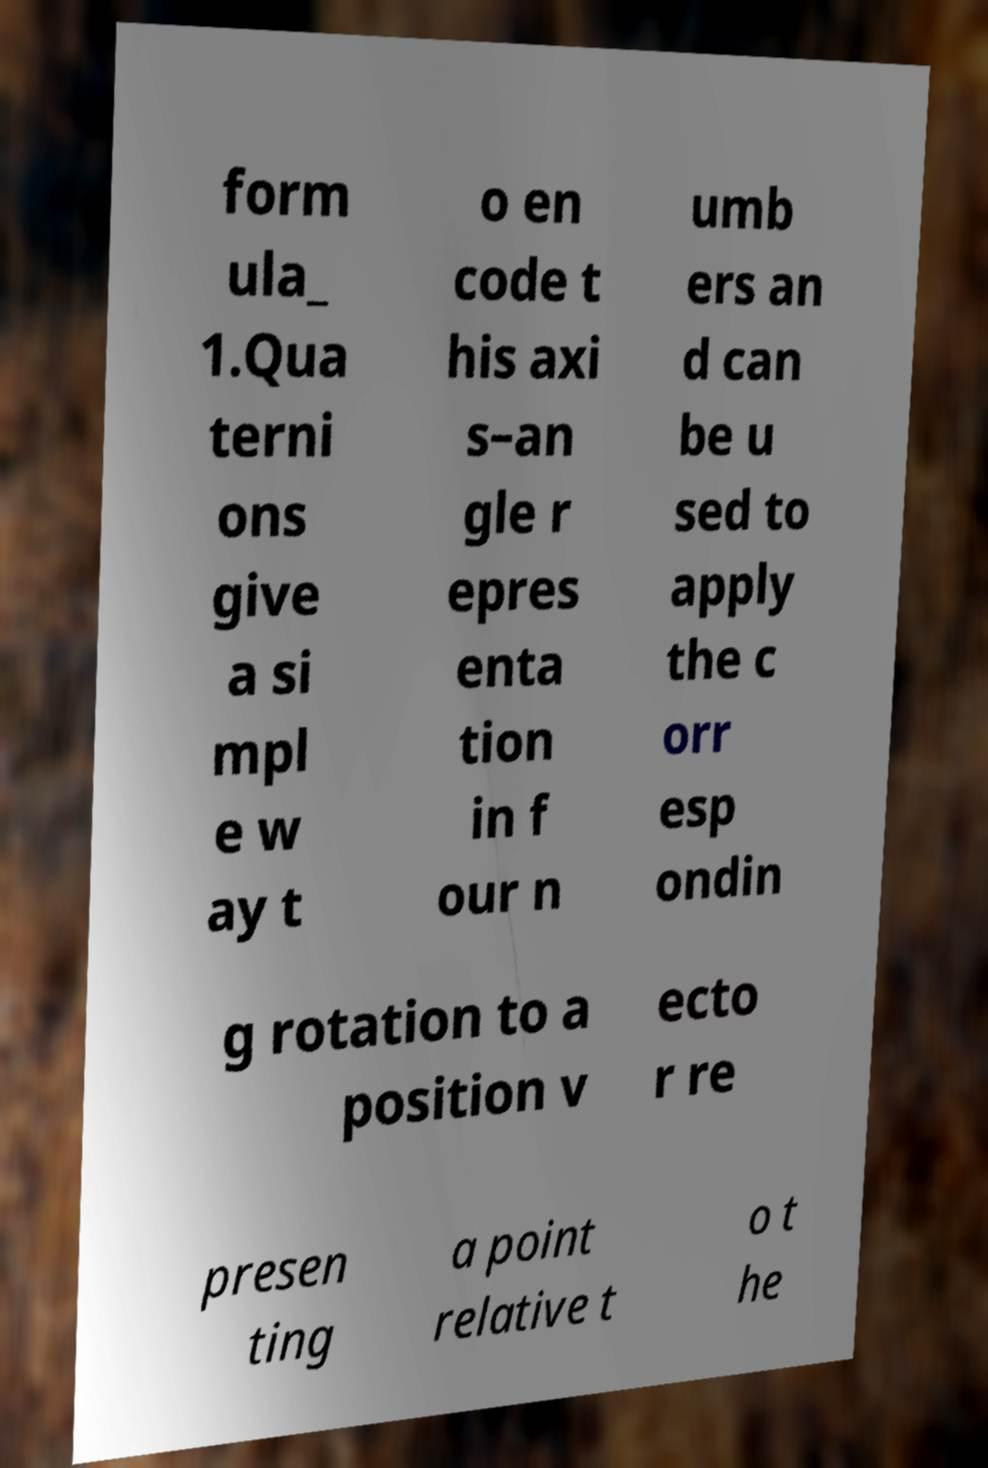I need the written content from this picture converted into text. Can you do that? form ula_ 1.Qua terni ons give a si mpl e w ay t o en code t his axi s–an gle r epres enta tion in f our n umb ers an d can be u sed to apply the c orr esp ondin g rotation to a position v ecto r re presen ting a point relative t o t he 